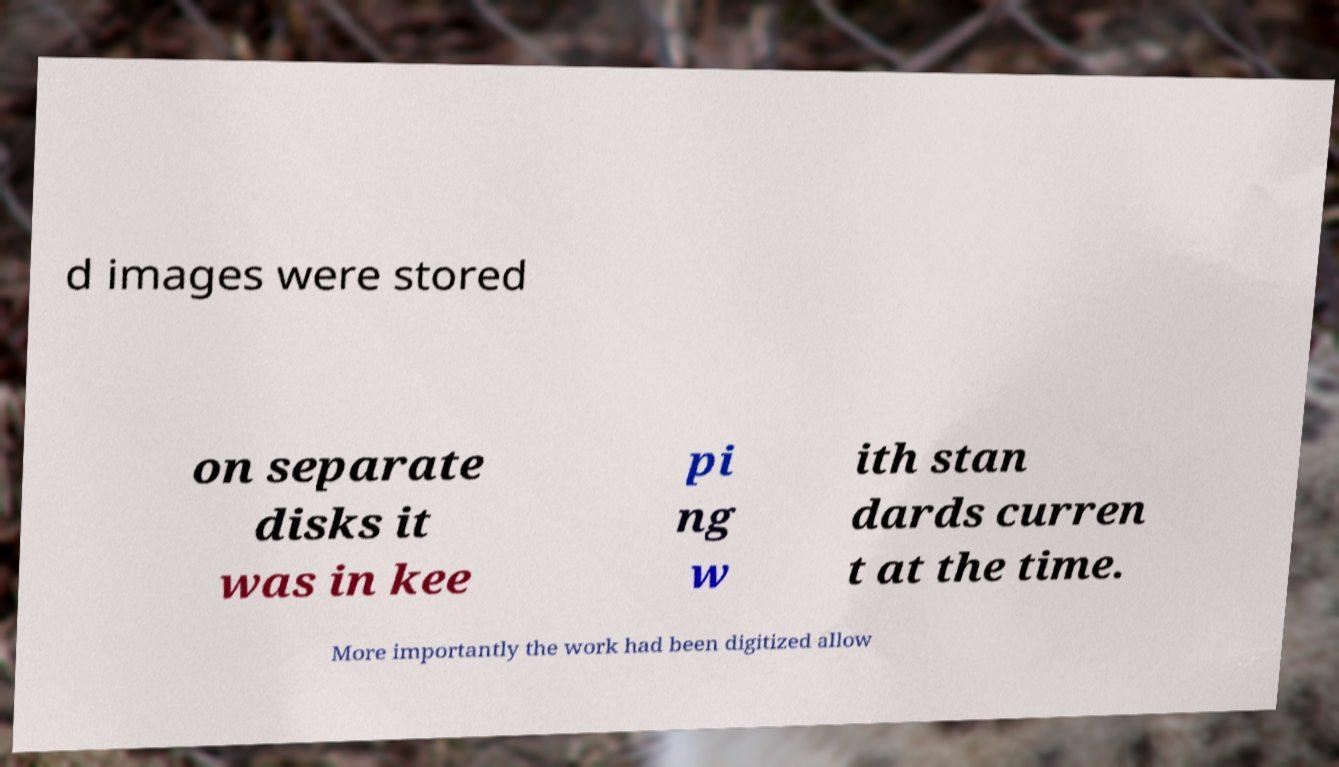Please identify and transcribe the text found in this image. d images were stored on separate disks it was in kee pi ng w ith stan dards curren t at the time. More importantly the work had been digitized allow 